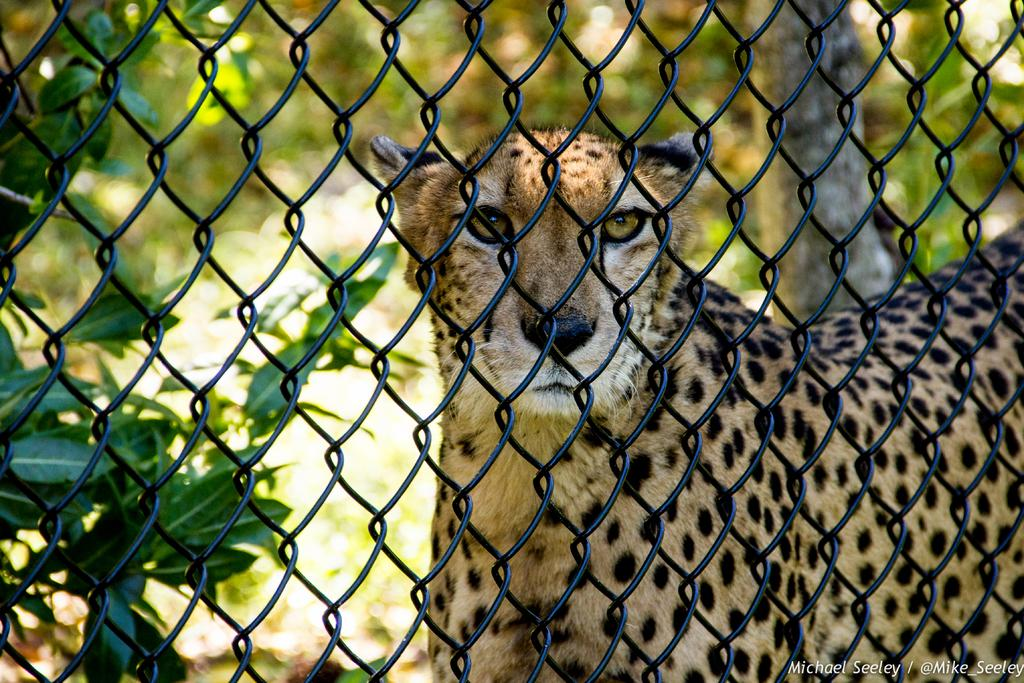What is the main feature of the image? The main feature of the image is a mesh. What can be seen through the mesh? Cheetahs and plants are visible through the mesh. How is the background of the image depicted? The background has a blurred view. What other object is present in the image? There is a tree trunk in the image. What type of authority figure can be seen swimming in the image? There is no authority figure or swimming activity depicted in the image. 